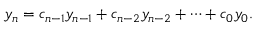<formula> <loc_0><loc_0><loc_500><loc_500>y _ { n } = c _ { n - 1 } y _ { n - 1 } + c _ { n - 2 } y _ { n - 2 } + \cdots + c _ { 0 } y _ { 0 } .</formula> 